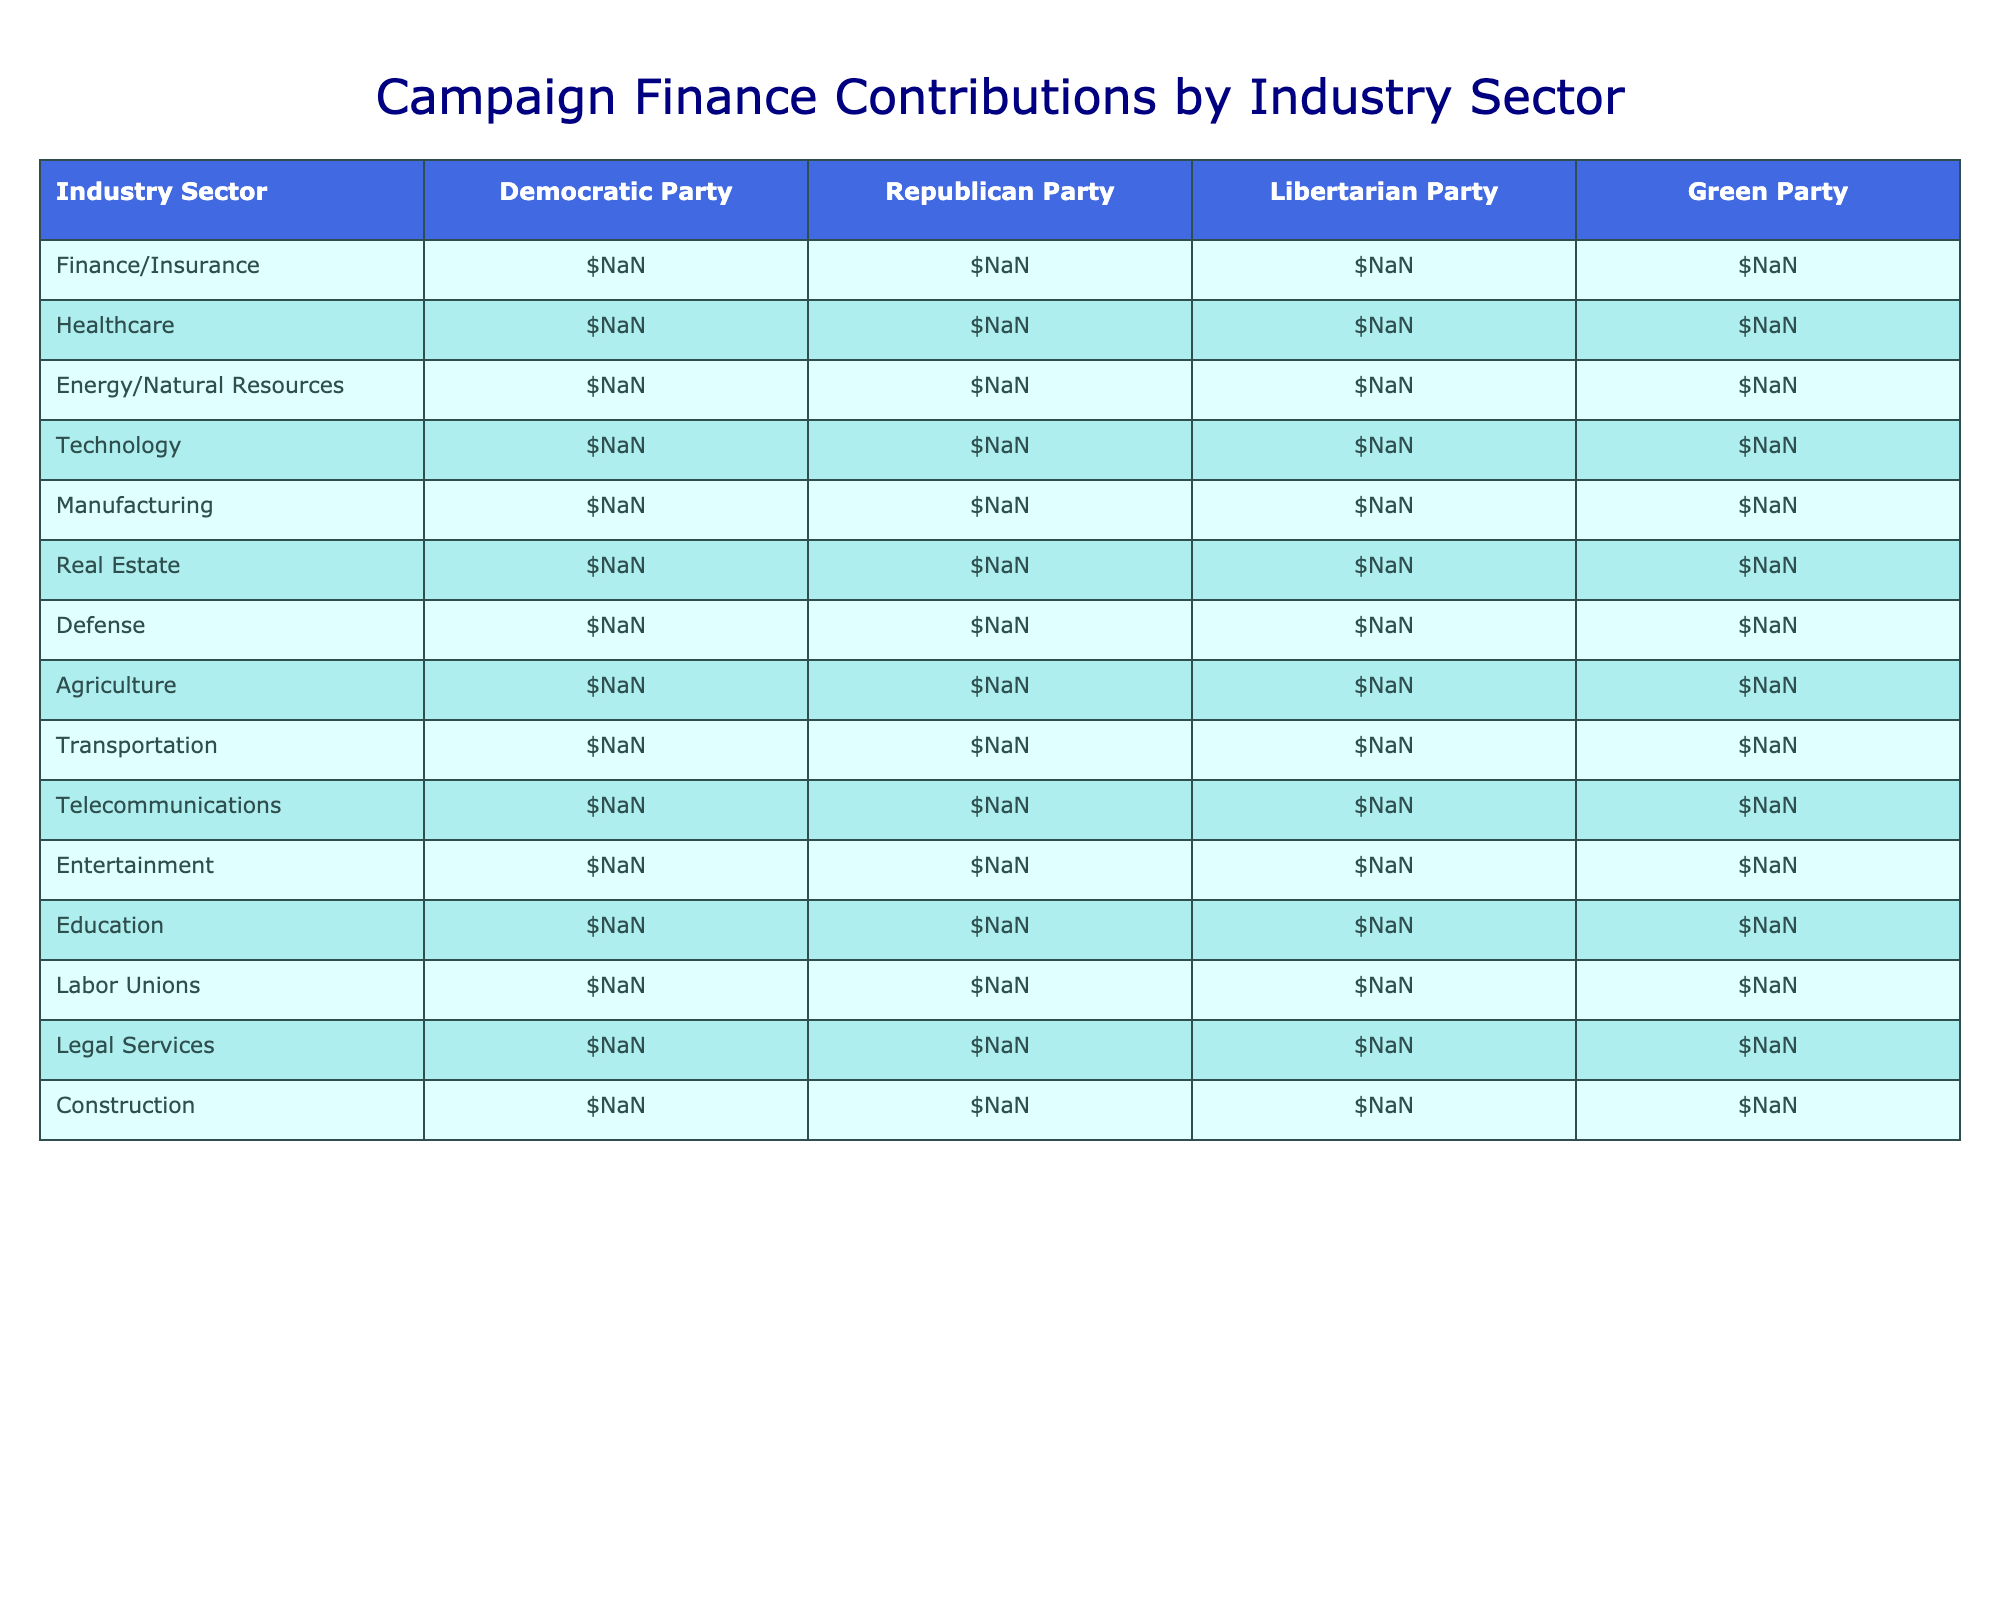What industry sector contributed the most to the Democratic Party? Looking at the table, the sector with the highest contribution to the Democratic Party is Technology, with a contribution of $51,400,000.
Answer: Technology Which party received the least amount from the Agriculture sector? The table shows that the Green Party received the least amount from the Agriculture sector, with a contribution of $1,600,000.
Answer: Green Party What is the combined total contribution from the Finance/Insurance and Healthcare sectors to the Republican Party? For the Republican Party, contributions from both sectors are $52,800,000 (Finance/Insurance) + $41,500,000 (Healthcare) = $94,300,000.
Answer: $94,300,000 Did the Libertarian Party receive more from the Energy/Natural Resources sector than from the Defense sector? The contributions for the Libertarian Party are $1,500,000 (Energy/Natural Resources) and $800,000 (Defense). Since $1,500,000 is greater than $800,000, the statement is true.
Answer: Yes Which sector's contribution to the Republican Party is closer to the contribution to the Democratic Party: Telecommunications or Labor Unions? The Republican Party received $22,100,000 from Telecommunications and $3,700,000 from Labor Unions. The Democratic Party received $24,700,000 (Telecommunications) and $32,600,000 (Labor Unions). The difference for Telecommunications is $2,600,000 and for Labor Unions is $1,300,000, thus Telecommunications is closer at $2,600,000 than Labor Unions at $1,300,000.
Answer: Telecommunications What is the average contribution from the Defense and Transportation sectors to both parties? The contributions to the Democratic Party from Defense and Transportation are $18,600,000 and $20,400,000, totaling $39,000,000, and divided by 2 gives an average of $19,500,000. For the Republican Party, the contributions are $27,300,000 and $25,600,000, totaling $52,900,000 with an average of $26,450,000. Hence, the average contribution considering both parties is ($19,500,000 + $26,450,000)/2 = $22,975,000.
Answer: $22,975,000 Which industry sector shows a significant difference in contributions between the Democratic and Republican parties? Analyzing the contributions, Technology shows a significant difference: $51,400,000 (Democratic) - $28,700,000 (Republican) = $22,700,000, indicating the Democratic Party received significantly more from this sector.
Answer: Technology Is the total contribution amount for the manufacturing sector higher than the average of all sectors for the Republican Party? The total contribution for the Manufacturing sector to the Republican Party is $36,200,000. The average contribution across all sectors for the Republican Party is calculated as ($52,800,000 + $41,500,000 + $39,600,000 + $28,700,000 + $36,200,000 + $34,900,000 + $27,300,000 + $23,800,000 + $25,600,000 + $22,100,000 + $14,800,000 + $9,300,000 + $3,700,000 + $16,200,000 + $21,900,000)/15 = $24,246,666. Since $36,200,000 is greater than $24,246,666, the answer is true.
Answer: Yes Which political party received the second-highest total from the Energy/Natural Resources sector? The table indicates that the Republican Party received the highest from the Energy/Natural Resources sector ($39,600,000), followed by the Green Party with $2,100,000. Therefore, the Green Party is the answer.
Answer: Green Party 